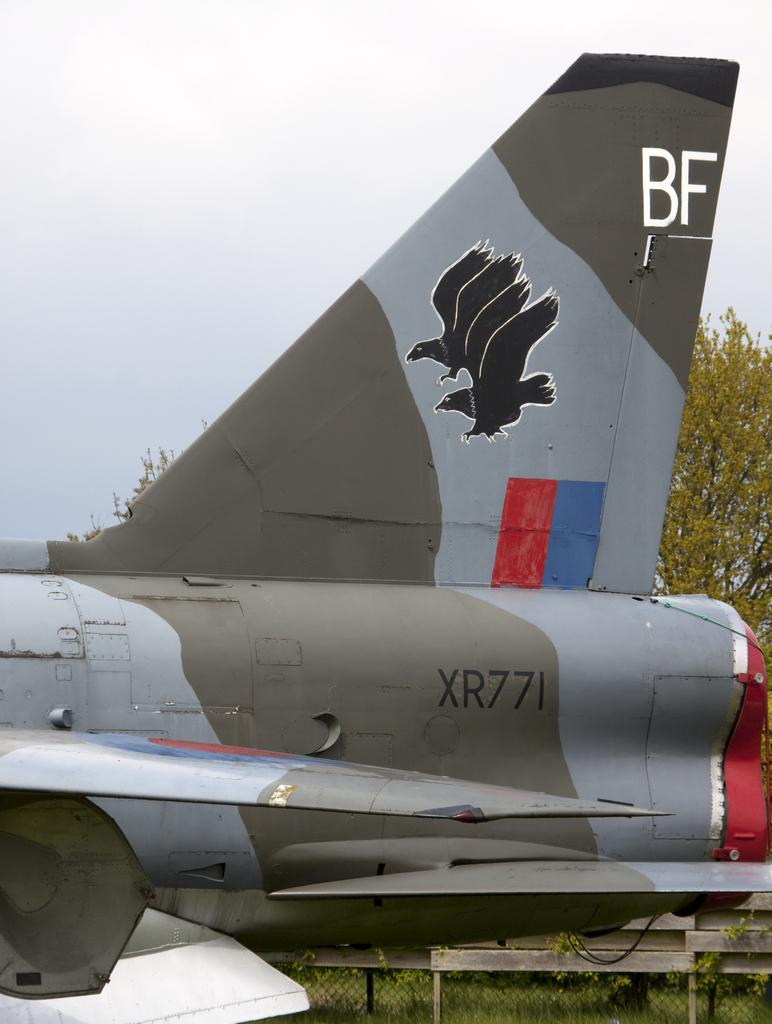Provide a one-sentence caption for the provided image. The rear section of an aircraft contains the label XR771. 